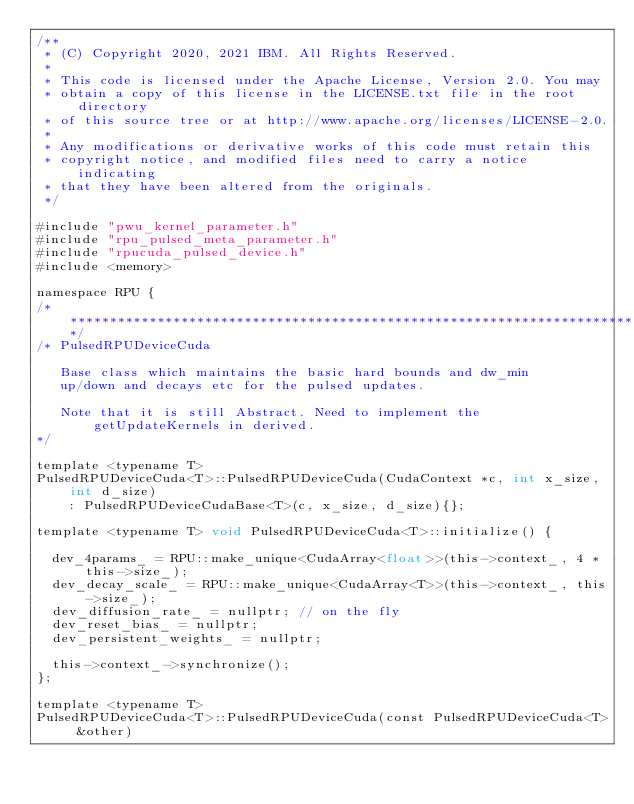Convert code to text. <code><loc_0><loc_0><loc_500><loc_500><_Cuda_>/**
 * (C) Copyright 2020, 2021 IBM. All Rights Reserved.
 *
 * This code is licensed under the Apache License, Version 2.0. You may
 * obtain a copy of this license in the LICENSE.txt file in the root directory
 * of this source tree or at http://www.apache.org/licenses/LICENSE-2.0.
 *
 * Any modifications or derivative works of this code must retain this
 * copyright notice, and modified files need to carry a notice indicating
 * that they have been altered from the originals.
 */

#include "pwu_kernel_parameter.h"
#include "rpu_pulsed_meta_parameter.h"
#include "rpucuda_pulsed_device.h"
#include <memory>

namespace RPU {
/******************************************************************************************/
/* PulsedRPUDeviceCuda

   Base class which maintains the basic hard bounds and dw_min
   up/down and decays etc for the pulsed updates.

   Note that it is still Abstract. Need to implement the getUpdateKernels in derived.
*/

template <typename T>
PulsedRPUDeviceCuda<T>::PulsedRPUDeviceCuda(CudaContext *c, int x_size, int d_size)
    : PulsedRPUDeviceCudaBase<T>(c, x_size, d_size){};

template <typename T> void PulsedRPUDeviceCuda<T>::initialize() {

  dev_4params_ = RPU::make_unique<CudaArray<float>>(this->context_, 4 * this->size_);
  dev_decay_scale_ = RPU::make_unique<CudaArray<T>>(this->context_, this->size_);
  dev_diffusion_rate_ = nullptr; // on the fly
  dev_reset_bias_ = nullptr;
  dev_persistent_weights_ = nullptr;

  this->context_->synchronize();
};

template <typename T>
PulsedRPUDeviceCuda<T>::PulsedRPUDeviceCuda(const PulsedRPUDeviceCuda<T> &other)</code> 